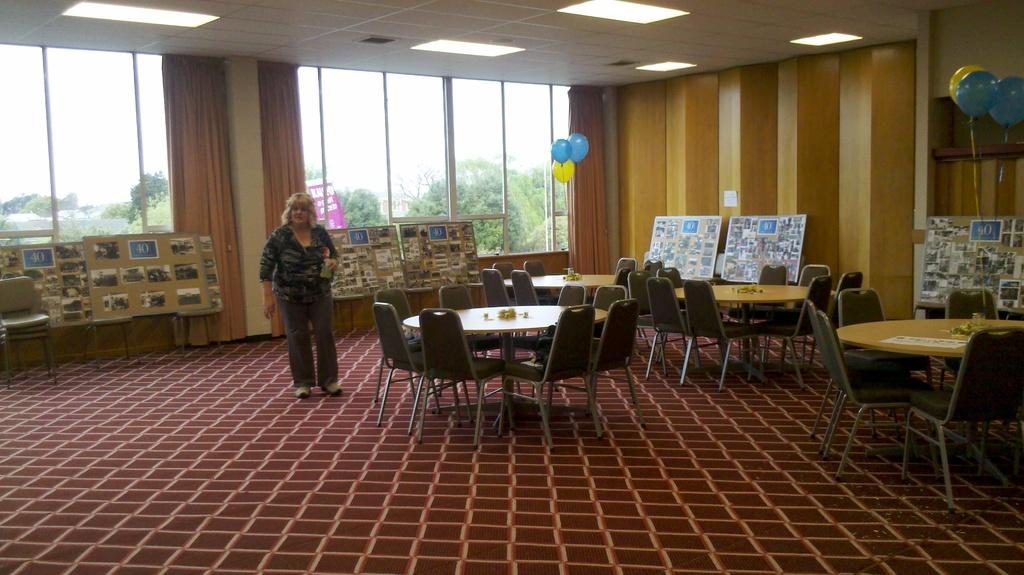Who is present in the image? There is a woman in the image. What objects can be seen in the image? There are boards, images, chairs, tables, and balloons in the image. What can be seen in the background of the image? There is a wall, curtains, a window, trees, and the sky visible in the background of the image. What type of smoke can be seen coming from the woman's mouth in the image? There is no smoke present in the image, and the woman's mouth is not depicted as emitting any smoke. 